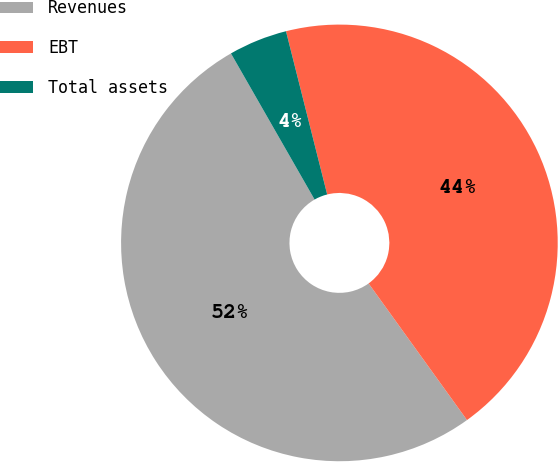<chart> <loc_0><loc_0><loc_500><loc_500><pie_chart><fcel>Revenues<fcel>EBT<fcel>Total assets<nl><fcel>51.66%<fcel>44.0%<fcel>4.34%<nl></chart> 